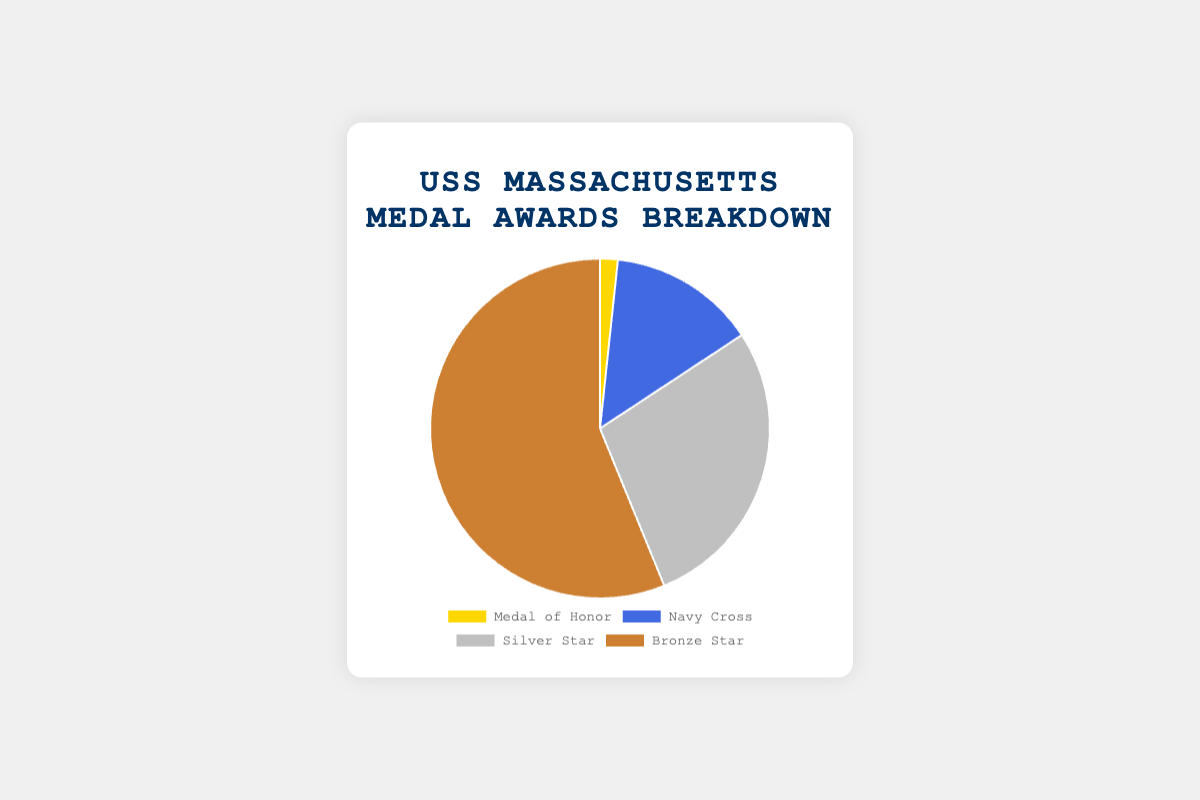What is the total number of awards for the crew of USS Massachusetts? To find the total number of awards, sum up the awards for each category: 3 (Medal of Honor) + 25 (Navy Cross) + 50 (Silver Star) + 100 (Bronze Star) = 178
Answer: 178 Which category has the highest number of medals? Review the data to see which category has the highest value. The categories are: Medal of Honor (3), Navy Cross (25), Silver Star (50), Bronze Star (100). The highest value is for Bronze Star with 100 medals
Answer: Bronze Star What percentage of the total medals is the Navy Cross? To find the percentage, divide the Navy Cross count by the total number of awards and multiply by 100. The Navy Cross count is 25, and the total is 178. So, (25 / 178) * 100 = ~14.04%
Answer: ~14.04% What is the difference in the number of medals between the Silver Star and Medal of Honor? Subtract the number of Medal of Honor medals from the number of Silver Star medals. Silver Star has 50, and Medal of Honor has 3. So, 50 - 3 = 47
Answer: 47 Are the number of Bronze Star medals greater than all other medal categories combined? Add up the counts for Medal of Honor, Navy Cross, and Silver Star, and compare it with the number of Bronze Star medals. Total medals for other categories: 3 + 25 + 50 = 78. Bronze Star is 100. Since 100 > 78, the answer is yes
Answer: yes What fraction of the medals are Silver Stars? Divide the number of Silver Star medals by the total number of medals. Silver Star is 50, total is 178. The fraction is 50 / 178 = ~0.28
Answer: ~0.28 Which medal category has the smallest number of awards, and how many are there? Identify the category with the lowest value: Medal of Honor (3), Navy Cross (25), Silver Star (50), Bronze Star (100). The smallest value is for Medal of Honor with 3 awards
Answer: Medal of Honor, 3 If the number of Bronze Star medals was reduced by half, would it still be the category with the highest number of medals? Halve the current Bronze Star count: 100 / 2 = 50. Compare it with the counts for other categories: Medal of Honor (3), Navy Cross (25), Silver Star (50). It would still be the highest count as 50 is equal to Silver Star which is the next highest.
Answer: Yes What are the colors representing each medal category? Identify the colors from the visual representation. The labels are usually noted by color, here they are: Medal of Honor (gold), Navy Cross (blue), Silver Star (silver), Bronze Star (brown)
Answer: gold, blue, silver, brown Is the combined total of Medal of Honor and Navy Cross medals less than Silver Star medals? Add the counts for Medal of Honor and Navy Cross: 3 + 25 = 28. Compare it with Silver Star count which is 50. Since 28 < 50, the answer is yes
Answer: Yes 